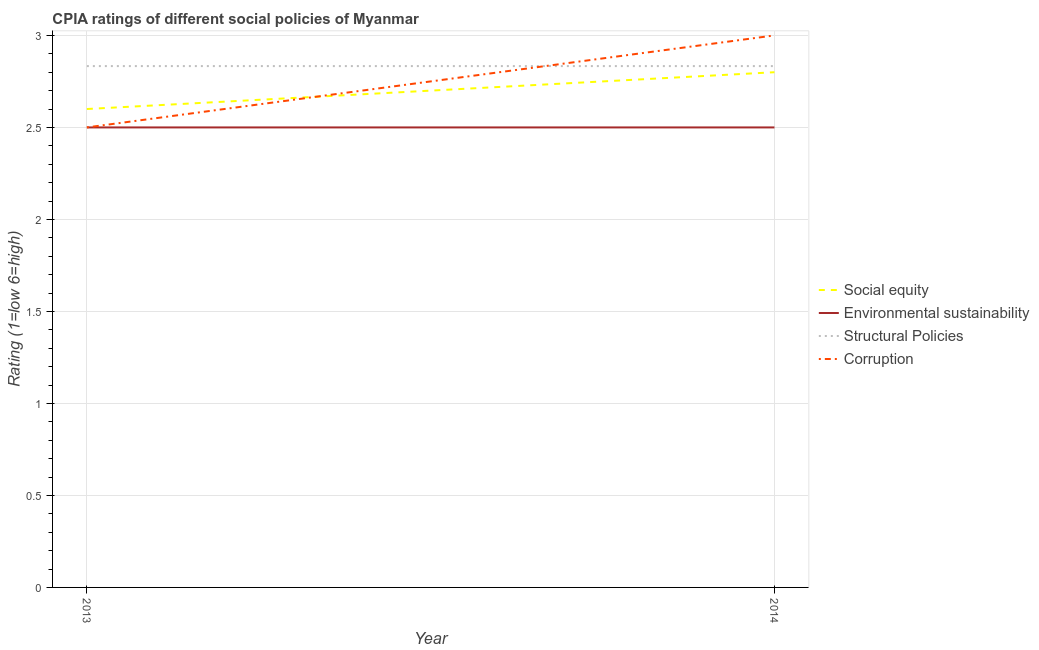Does the line corresponding to cpia rating of social equity intersect with the line corresponding to cpia rating of environmental sustainability?
Give a very brief answer. No. Is the number of lines equal to the number of legend labels?
Offer a very short reply. Yes. What is the cpia rating of environmental sustainability in 2014?
Provide a succinct answer. 2.5. Across all years, what is the maximum cpia rating of environmental sustainability?
Ensure brevity in your answer.  2.5. Across all years, what is the minimum cpia rating of corruption?
Offer a terse response. 2.5. In which year was the cpia rating of environmental sustainability minimum?
Provide a succinct answer. 2013. What is the total cpia rating of social equity in the graph?
Make the answer very short. 5.4. What is the difference between the cpia rating of environmental sustainability in 2014 and the cpia rating of social equity in 2013?
Ensure brevity in your answer.  -0.1. What is the average cpia rating of social equity per year?
Provide a succinct answer. 2.7. In the year 2013, what is the difference between the cpia rating of environmental sustainability and cpia rating of structural policies?
Your answer should be very brief. -0.33. In how many years, is the cpia rating of social equity greater than 1.6?
Your answer should be very brief. 2. How many lines are there?
Your response must be concise. 4. How many years are there in the graph?
Provide a short and direct response. 2. How are the legend labels stacked?
Give a very brief answer. Vertical. What is the title of the graph?
Your answer should be compact. CPIA ratings of different social policies of Myanmar. Does "Compensation of employees" appear as one of the legend labels in the graph?
Keep it short and to the point. No. What is the Rating (1=low 6=high) of Structural Policies in 2013?
Keep it short and to the point. 2.83. What is the Rating (1=low 6=high) of Structural Policies in 2014?
Give a very brief answer. 2.83. What is the Rating (1=low 6=high) in Corruption in 2014?
Keep it short and to the point. 3. Across all years, what is the maximum Rating (1=low 6=high) of Environmental sustainability?
Provide a short and direct response. 2.5. Across all years, what is the maximum Rating (1=low 6=high) of Structural Policies?
Offer a terse response. 2.83. Across all years, what is the minimum Rating (1=low 6=high) in Environmental sustainability?
Your answer should be very brief. 2.5. Across all years, what is the minimum Rating (1=low 6=high) of Structural Policies?
Your answer should be compact. 2.83. What is the total Rating (1=low 6=high) of Structural Policies in the graph?
Give a very brief answer. 5.67. What is the difference between the Rating (1=low 6=high) in Environmental sustainability in 2013 and that in 2014?
Your answer should be compact. 0. What is the difference between the Rating (1=low 6=high) of Structural Policies in 2013 and that in 2014?
Provide a succinct answer. 0. What is the difference between the Rating (1=low 6=high) in Corruption in 2013 and that in 2014?
Provide a short and direct response. -0.5. What is the difference between the Rating (1=low 6=high) in Social equity in 2013 and the Rating (1=low 6=high) in Structural Policies in 2014?
Ensure brevity in your answer.  -0.23. What is the difference between the Rating (1=low 6=high) of Social equity in 2013 and the Rating (1=low 6=high) of Corruption in 2014?
Your answer should be compact. -0.4. What is the difference between the Rating (1=low 6=high) of Environmental sustainability in 2013 and the Rating (1=low 6=high) of Corruption in 2014?
Offer a very short reply. -0.5. What is the average Rating (1=low 6=high) in Social equity per year?
Offer a terse response. 2.7. What is the average Rating (1=low 6=high) in Environmental sustainability per year?
Your answer should be compact. 2.5. What is the average Rating (1=low 6=high) in Structural Policies per year?
Your response must be concise. 2.83. What is the average Rating (1=low 6=high) in Corruption per year?
Keep it short and to the point. 2.75. In the year 2013, what is the difference between the Rating (1=low 6=high) of Social equity and Rating (1=low 6=high) of Environmental sustainability?
Your answer should be compact. 0.1. In the year 2013, what is the difference between the Rating (1=low 6=high) in Social equity and Rating (1=low 6=high) in Structural Policies?
Ensure brevity in your answer.  -0.23. In the year 2013, what is the difference between the Rating (1=low 6=high) of Social equity and Rating (1=low 6=high) of Corruption?
Your answer should be compact. 0.1. In the year 2013, what is the difference between the Rating (1=low 6=high) of Environmental sustainability and Rating (1=low 6=high) of Structural Policies?
Give a very brief answer. -0.33. In the year 2013, what is the difference between the Rating (1=low 6=high) in Structural Policies and Rating (1=low 6=high) in Corruption?
Ensure brevity in your answer.  0.33. In the year 2014, what is the difference between the Rating (1=low 6=high) in Social equity and Rating (1=low 6=high) in Environmental sustainability?
Your answer should be very brief. 0.3. In the year 2014, what is the difference between the Rating (1=low 6=high) of Social equity and Rating (1=low 6=high) of Structural Policies?
Make the answer very short. -0.03. In the year 2014, what is the difference between the Rating (1=low 6=high) in Social equity and Rating (1=low 6=high) in Corruption?
Your answer should be compact. -0.2. In the year 2014, what is the difference between the Rating (1=low 6=high) of Environmental sustainability and Rating (1=low 6=high) of Structural Policies?
Keep it short and to the point. -0.33. In the year 2014, what is the difference between the Rating (1=low 6=high) of Environmental sustainability and Rating (1=low 6=high) of Corruption?
Provide a short and direct response. -0.5. In the year 2014, what is the difference between the Rating (1=low 6=high) of Structural Policies and Rating (1=low 6=high) of Corruption?
Give a very brief answer. -0.17. What is the ratio of the Rating (1=low 6=high) in Social equity in 2013 to that in 2014?
Keep it short and to the point. 0.93. What is the ratio of the Rating (1=low 6=high) of Structural Policies in 2013 to that in 2014?
Ensure brevity in your answer.  1. What is the ratio of the Rating (1=low 6=high) in Corruption in 2013 to that in 2014?
Keep it short and to the point. 0.83. What is the difference between the highest and the second highest Rating (1=low 6=high) in Social equity?
Offer a very short reply. 0.2. What is the difference between the highest and the second highest Rating (1=low 6=high) of Structural Policies?
Ensure brevity in your answer.  0. What is the difference between the highest and the lowest Rating (1=low 6=high) in Social equity?
Your response must be concise. 0.2. What is the difference between the highest and the lowest Rating (1=low 6=high) of Environmental sustainability?
Your response must be concise. 0. 